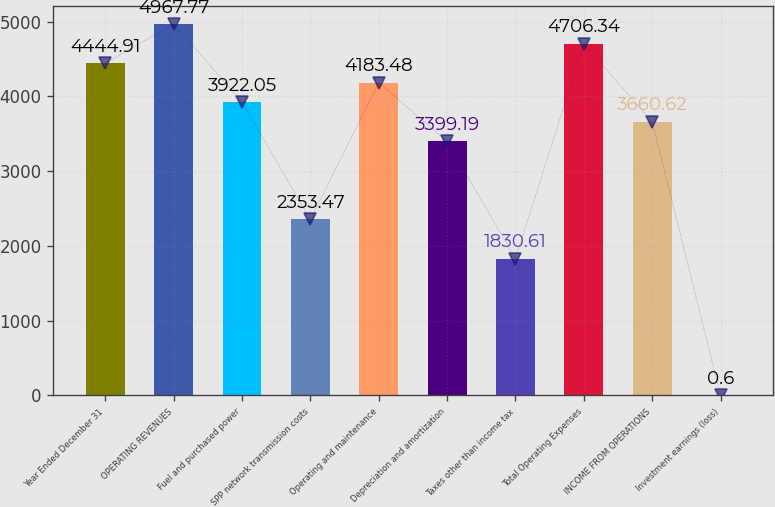Convert chart. <chart><loc_0><loc_0><loc_500><loc_500><bar_chart><fcel>Year Ended December 31<fcel>OPERATING REVENUES<fcel>Fuel and purchased power<fcel>SPP network transmission costs<fcel>Operating and maintenance<fcel>Depreciation and amortization<fcel>Taxes other than income tax<fcel>Total Operating Expenses<fcel>INCOME FROM OPERATIONS<fcel>Investment earnings (loss)<nl><fcel>4444.91<fcel>4967.77<fcel>3922.05<fcel>2353.47<fcel>4183.48<fcel>3399.19<fcel>1830.61<fcel>4706.34<fcel>3660.62<fcel>0.6<nl></chart> 